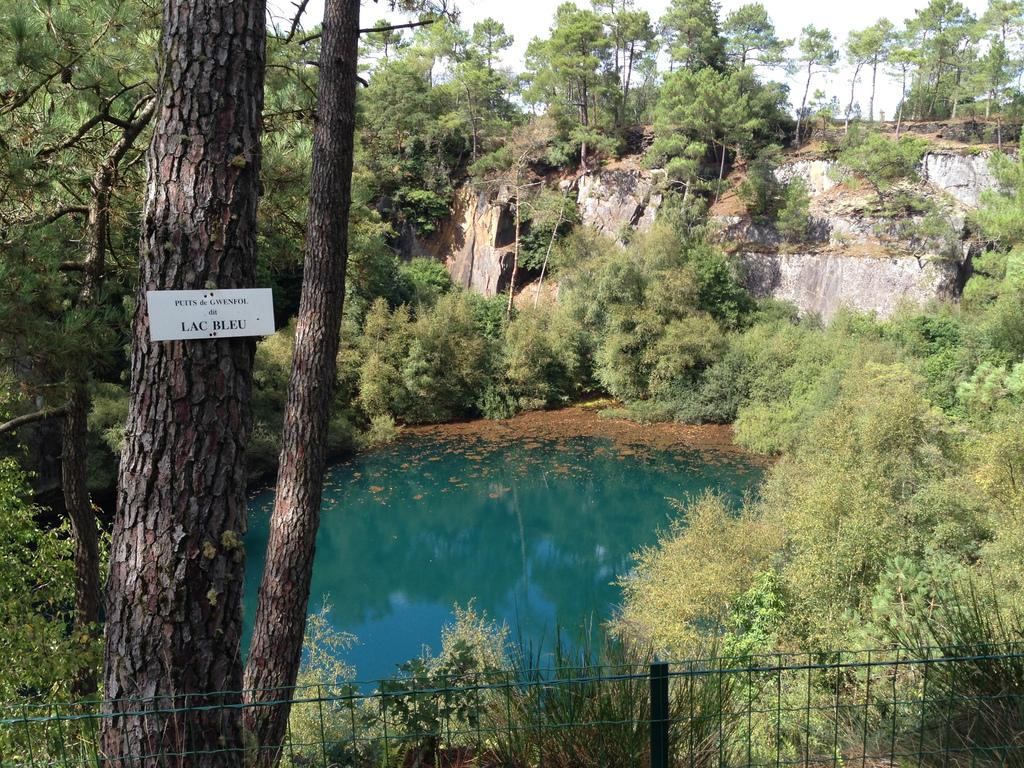What is attached to the tree trunk in the image? There is a board attached to a tree trunk in the image. What type of vegetation can be seen in the image? There are plants and trees in the image. What can be seen in the water in the image? The image does not provide details about what can be seen in the water. What type of barrier is present in the image? There is a fence in the image. What is visible in the background of the image? The sky is visible in the background of the image. What type of fruit is being traded in the image? There is no indication of fruit or trade in the image; it features a board attached to a tree trunk, plants, trees, water, a fence, and the sky. 